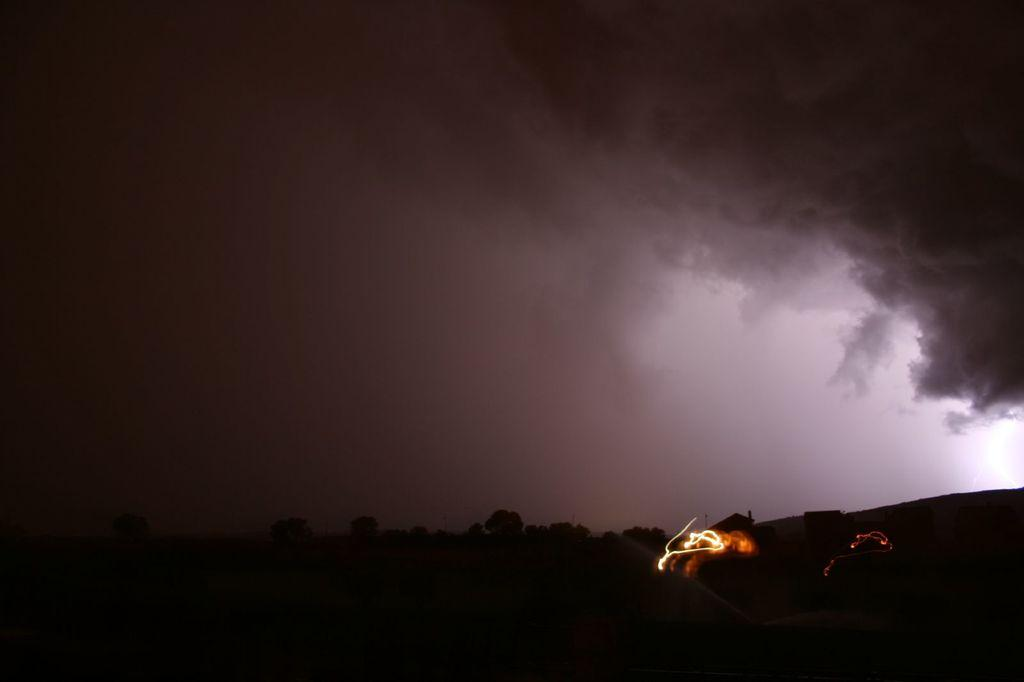What type of vegetation can be seen in the image? There are trees in the image. What type of structures are visible in the image? There are houses in the image. What is visible in the sky in the image? The sky is visible in the image. What can be observed in the sky in the image? Clouds are present in the sky. Where is the stream located in the image? There is no stream present in the image. What type of mark can be seen on the trees in the image? There are no marks visible on the trees in the image. 